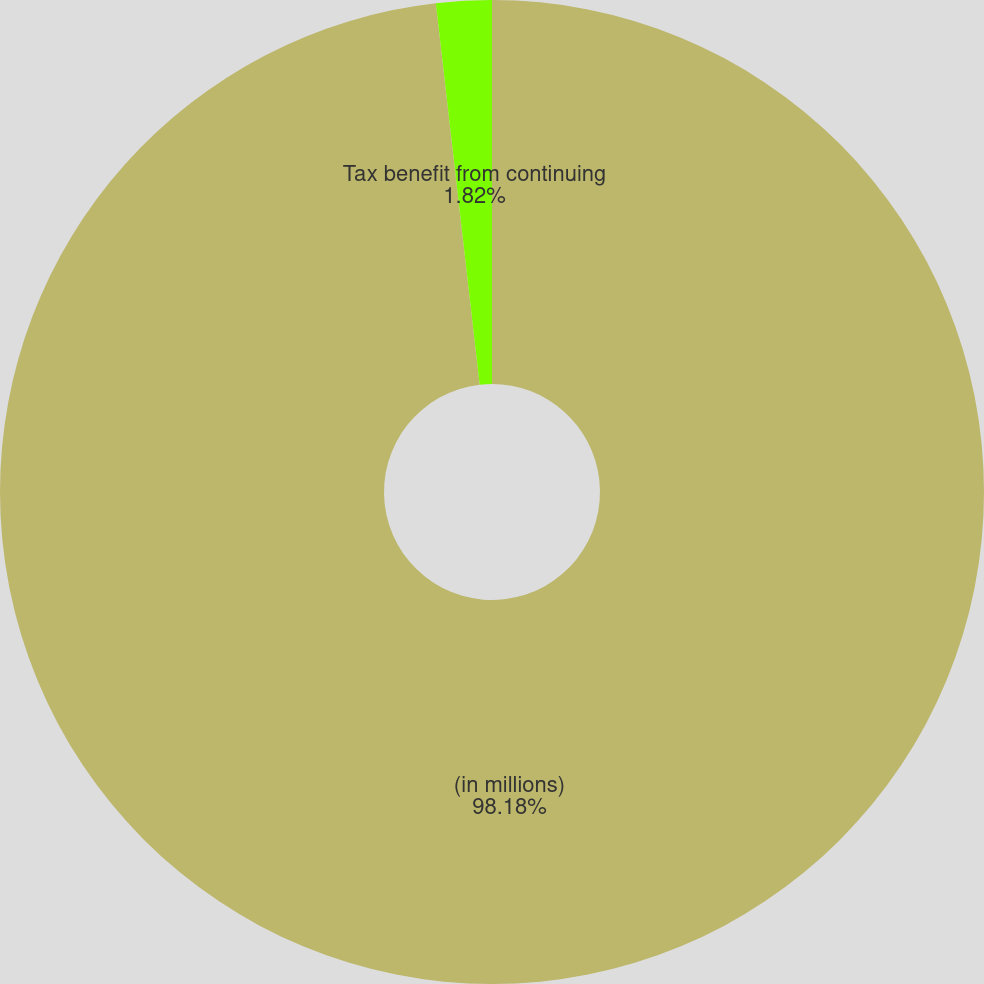Convert chart. <chart><loc_0><loc_0><loc_500><loc_500><pie_chart><fcel>(in millions)<fcel>Tax benefit from continuing<nl><fcel>98.18%<fcel>1.82%<nl></chart> 